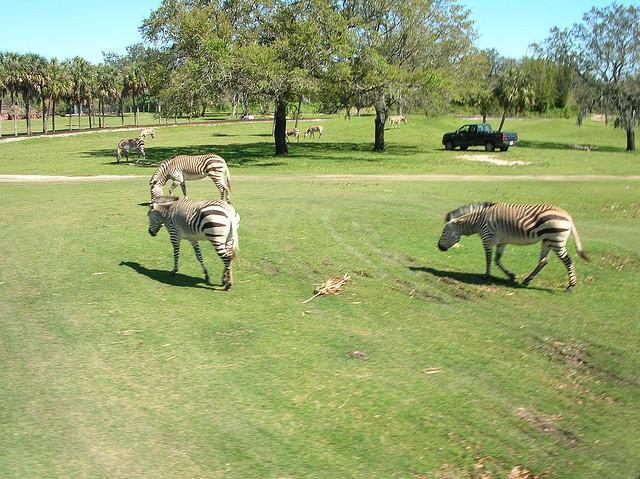How many vehicles are in this picture?
Give a very brief answer. 1. How many zebras are there in the foreground?
Give a very brief answer. 3. How many zebras are there?
Give a very brief answer. 3. How many trains are there?
Give a very brief answer. 0. 